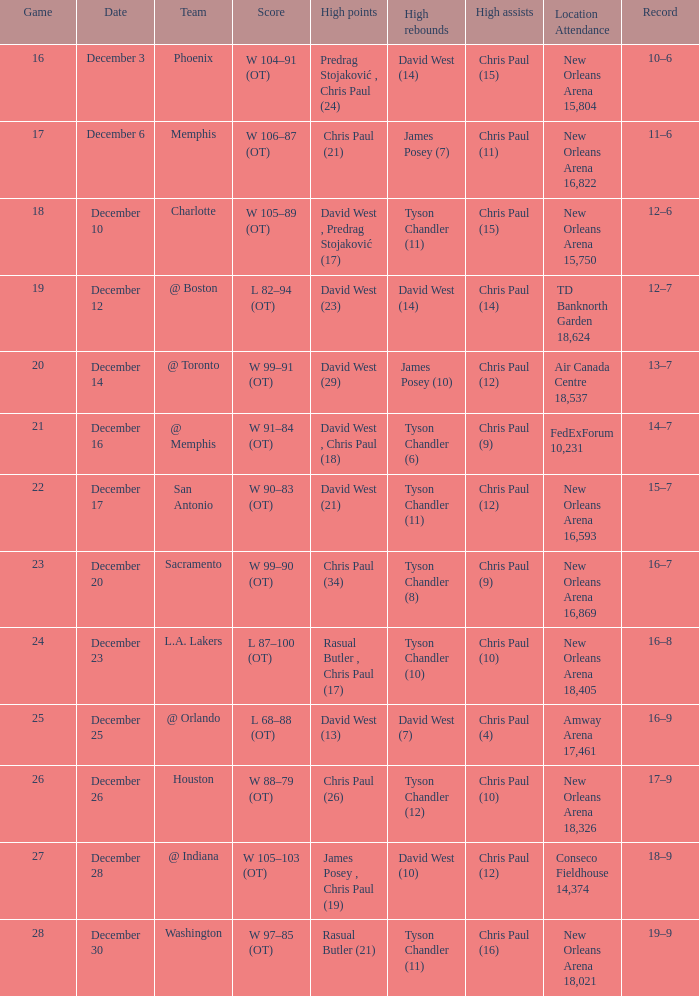What is Score, when Team is "@ Memphis"? W 91–84 (OT). 